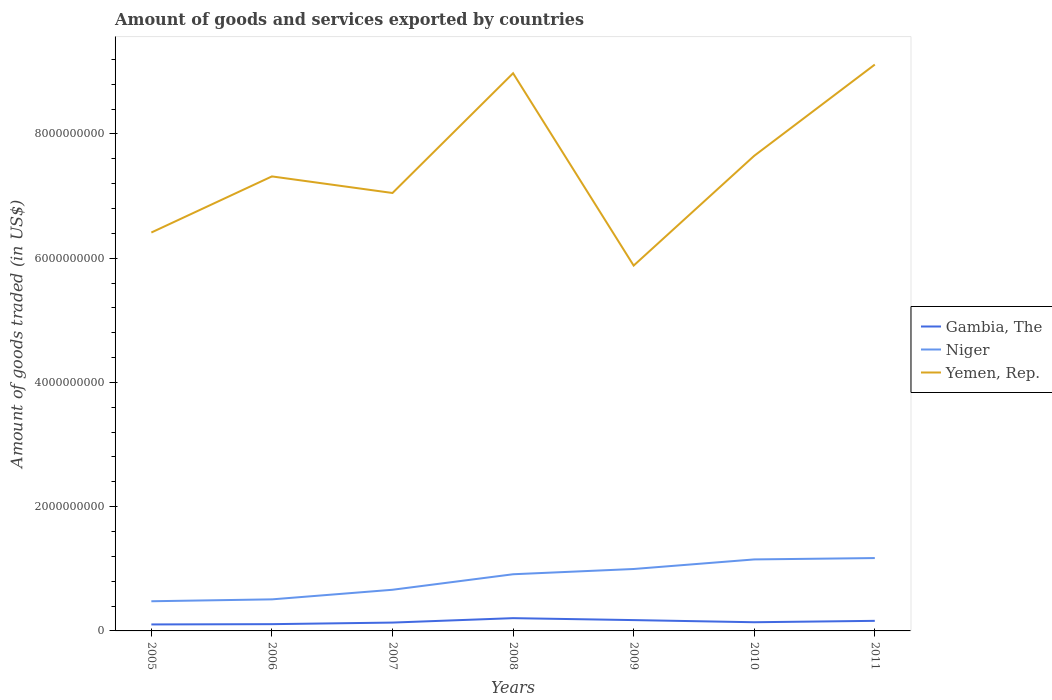Does the line corresponding to Niger intersect with the line corresponding to Gambia, The?
Offer a very short reply. No. Across all years, what is the maximum total amount of goods and services exported in Yemen, Rep.?
Offer a terse response. 5.88e+09. What is the total total amount of goods and services exported in Niger in the graph?
Your answer should be compact. -2.17e+07. What is the difference between the highest and the second highest total amount of goods and services exported in Gambia, The?
Your response must be concise. 1.01e+08. Is the total amount of goods and services exported in Niger strictly greater than the total amount of goods and services exported in Yemen, Rep. over the years?
Provide a short and direct response. Yes. How many lines are there?
Your answer should be compact. 3. How many years are there in the graph?
Provide a short and direct response. 7. What is the difference between two consecutive major ticks on the Y-axis?
Keep it short and to the point. 2.00e+09. Does the graph contain any zero values?
Ensure brevity in your answer.  No. Where does the legend appear in the graph?
Your answer should be very brief. Center right. What is the title of the graph?
Your response must be concise. Amount of goods and services exported by countries. What is the label or title of the X-axis?
Make the answer very short. Years. What is the label or title of the Y-axis?
Offer a terse response. Amount of goods traded (in US$). What is the Amount of goods traded (in US$) of Gambia, The in 2005?
Give a very brief answer. 1.04e+08. What is the Amount of goods traded (in US$) in Niger in 2005?
Provide a succinct answer. 4.78e+08. What is the Amount of goods traded (in US$) of Yemen, Rep. in 2005?
Offer a very short reply. 6.41e+09. What is the Amount of goods traded (in US$) of Gambia, The in 2006?
Your response must be concise. 1.09e+08. What is the Amount of goods traded (in US$) in Niger in 2006?
Offer a very short reply. 5.08e+08. What is the Amount of goods traded (in US$) in Yemen, Rep. in 2006?
Make the answer very short. 7.32e+09. What is the Amount of goods traded (in US$) of Gambia, The in 2007?
Your answer should be compact. 1.34e+08. What is the Amount of goods traded (in US$) of Niger in 2007?
Offer a terse response. 6.63e+08. What is the Amount of goods traded (in US$) in Yemen, Rep. in 2007?
Ensure brevity in your answer.  7.05e+09. What is the Amount of goods traded (in US$) of Gambia, The in 2008?
Offer a terse response. 2.06e+08. What is the Amount of goods traded (in US$) in Niger in 2008?
Provide a short and direct response. 9.12e+08. What is the Amount of goods traded (in US$) in Yemen, Rep. in 2008?
Give a very brief answer. 8.98e+09. What is the Amount of goods traded (in US$) in Gambia, The in 2009?
Ensure brevity in your answer.  1.74e+08. What is the Amount of goods traded (in US$) in Niger in 2009?
Your answer should be very brief. 9.97e+08. What is the Amount of goods traded (in US$) of Yemen, Rep. in 2009?
Make the answer very short. 5.88e+09. What is the Amount of goods traded (in US$) of Gambia, The in 2010?
Keep it short and to the point. 1.40e+08. What is the Amount of goods traded (in US$) of Niger in 2010?
Offer a very short reply. 1.15e+09. What is the Amount of goods traded (in US$) of Yemen, Rep. in 2010?
Provide a short and direct response. 7.65e+09. What is the Amount of goods traded (in US$) in Gambia, The in 2011?
Offer a very short reply. 1.62e+08. What is the Amount of goods traded (in US$) in Niger in 2011?
Offer a very short reply. 1.17e+09. What is the Amount of goods traded (in US$) in Yemen, Rep. in 2011?
Provide a succinct answer. 9.12e+09. Across all years, what is the maximum Amount of goods traded (in US$) in Gambia, The?
Provide a succinct answer. 2.06e+08. Across all years, what is the maximum Amount of goods traded (in US$) in Niger?
Offer a very short reply. 1.17e+09. Across all years, what is the maximum Amount of goods traded (in US$) of Yemen, Rep.?
Make the answer very short. 9.12e+09. Across all years, what is the minimum Amount of goods traded (in US$) of Gambia, The?
Your response must be concise. 1.04e+08. Across all years, what is the minimum Amount of goods traded (in US$) in Niger?
Offer a terse response. 4.78e+08. Across all years, what is the minimum Amount of goods traded (in US$) in Yemen, Rep.?
Your answer should be very brief. 5.88e+09. What is the total Amount of goods traded (in US$) of Gambia, The in the graph?
Make the answer very short. 1.03e+09. What is the total Amount of goods traded (in US$) of Niger in the graph?
Provide a short and direct response. 5.88e+09. What is the total Amount of goods traded (in US$) in Yemen, Rep. in the graph?
Provide a succinct answer. 5.24e+1. What is the difference between the Amount of goods traded (in US$) in Gambia, The in 2005 and that in 2006?
Ensure brevity in your answer.  -4.54e+06. What is the difference between the Amount of goods traded (in US$) in Niger in 2005 and that in 2006?
Make the answer very short. -3.04e+07. What is the difference between the Amount of goods traded (in US$) in Yemen, Rep. in 2005 and that in 2006?
Provide a short and direct response. -9.03e+08. What is the difference between the Amount of goods traded (in US$) of Gambia, The in 2005 and that in 2007?
Give a very brief answer. -3.00e+07. What is the difference between the Amount of goods traded (in US$) of Niger in 2005 and that in 2007?
Your answer should be compact. -1.85e+08. What is the difference between the Amount of goods traded (in US$) in Yemen, Rep. in 2005 and that in 2007?
Make the answer very short. -6.36e+08. What is the difference between the Amount of goods traded (in US$) of Gambia, The in 2005 and that in 2008?
Your answer should be very brief. -1.01e+08. What is the difference between the Amount of goods traded (in US$) in Niger in 2005 and that in 2008?
Your answer should be compact. -4.35e+08. What is the difference between the Amount of goods traded (in US$) in Yemen, Rep. in 2005 and that in 2008?
Make the answer very short. -2.56e+09. What is the difference between the Amount of goods traded (in US$) of Gambia, The in 2005 and that in 2009?
Your answer should be compact. -6.99e+07. What is the difference between the Amount of goods traded (in US$) in Niger in 2005 and that in 2009?
Ensure brevity in your answer.  -5.19e+08. What is the difference between the Amount of goods traded (in US$) of Yemen, Rep. in 2005 and that in 2009?
Provide a short and direct response. 5.32e+08. What is the difference between the Amount of goods traded (in US$) of Gambia, The in 2005 and that in 2010?
Give a very brief answer. -3.56e+07. What is the difference between the Amount of goods traded (in US$) of Niger in 2005 and that in 2010?
Offer a very short reply. -6.73e+08. What is the difference between the Amount of goods traded (in US$) in Yemen, Rep. in 2005 and that in 2010?
Keep it short and to the point. -1.24e+09. What is the difference between the Amount of goods traded (in US$) in Gambia, The in 2005 and that in 2011?
Keep it short and to the point. -5.78e+07. What is the difference between the Amount of goods traded (in US$) of Niger in 2005 and that in 2011?
Your response must be concise. -6.95e+08. What is the difference between the Amount of goods traded (in US$) in Yemen, Rep. in 2005 and that in 2011?
Offer a terse response. -2.70e+09. What is the difference between the Amount of goods traded (in US$) of Gambia, The in 2006 and that in 2007?
Your response must be concise. -2.55e+07. What is the difference between the Amount of goods traded (in US$) of Niger in 2006 and that in 2007?
Provide a succinct answer. -1.55e+08. What is the difference between the Amount of goods traded (in US$) in Yemen, Rep. in 2006 and that in 2007?
Provide a short and direct response. 2.67e+08. What is the difference between the Amount of goods traded (in US$) in Gambia, The in 2006 and that in 2008?
Make the answer very short. -9.66e+07. What is the difference between the Amount of goods traded (in US$) of Niger in 2006 and that in 2008?
Your response must be concise. -4.04e+08. What is the difference between the Amount of goods traded (in US$) of Yemen, Rep. in 2006 and that in 2008?
Keep it short and to the point. -1.66e+09. What is the difference between the Amount of goods traded (in US$) of Gambia, The in 2006 and that in 2009?
Your response must be concise. -6.53e+07. What is the difference between the Amount of goods traded (in US$) of Niger in 2006 and that in 2009?
Provide a short and direct response. -4.89e+08. What is the difference between the Amount of goods traded (in US$) in Yemen, Rep. in 2006 and that in 2009?
Offer a terse response. 1.44e+09. What is the difference between the Amount of goods traded (in US$) of Gambia, The in 2006 and that in 2010?
Your response must be concise. -3.11e+07. What is the difference between the Amount of goods traded (in US$) in Niger in 2006 and that in 2010?
Your answer should be compact. -6.43e+08. What is the difference between the Amount of goods traded (in US$) in Yemen, Rep. in 2006 and that in 2010?
Keep it short and to the point. -3.32e+08. What is the difference between the Amount of goods traded (in US$) in Gambia, The in 2006 and that in 2011?
Your response must be concise. -5.33e+07. What is the difference between the Amount of goods traded (in US$) in Niger in 2006 and that in 2011?
Provide a short and direct response. -6.65e+08. What is the difference between the Amount of goods traded (in US$) in Yemen, Rep. in 2006 and that in 2011?
Ensure brevity in your answer.  -1.80e+09. What is the difference between the Amount of goods traded (in US$) in Gambia, The in 2007 and that in 2008?
Make the answer very short. -7.12e+07. What is the difference between the Amount of goods traded (in US$) in Niger in 2007 and that in 2008?
Make the answer very short. -2.50e+08. What is the difference between the Amount of goods traded (in US$) in Yemen, Rep. in 2007 and that in 2008?
Your answer should be very brief. -1.93e+09. What is the difference between the Amount of goods traded (in US$) in Gambia, The in 2007 and that in 2009?
Your answer should be compact. -3.99e+07. What is the difference between the Amount of goods traded (in US$) in Niger in 2007 and that in 2009?
Your answer should be compact. -3.34e+08. What is the difference between the Amount of goods traded (in US$) in Yemen, Rep. in 2007 and that in 2009?
Provide a short and direct response. 1.17e+09. What is the difference between the Amount of goods traded (in US$) of Gambia, The in 2007 and that in 2010?
Make the answer very short. -5.60e+06. What is the difference between the Amount of goods traded (in US$) of Niger in 2007 and that in 2010?
Your answer should be compact. -4.88e+08. What is the difference between the Amount of goods traded (in US$) of Yemen, Rep. in 2007 and that in 2010?
Offer a very short reply. -5.99e+08. What is the difference between the Amount of goods traded (in US$) in Gambia, The in 2007 and that in 2011?
Give a very brief answer. -2.78e+07. What is the difference between the Amount of goods traded (in US$) of Niger in 2007 and that in 2011?
Make the answer very short. -5.10e+08. What is the difference between the Amount of goods traded (in US$) of Yemen, Rep. in 2007 and that in 2011?
Your response must be concise. -2.07e+09. What is the difference between the Amount of goods traded (in US$) of Gambia, The in 2008 and that in 2009?
Ensure brevity in your answer.  3.13e+07. What is the difference between the Amount of goods traded (in US$) in Niger in 2008 and that in 2009?
Keep it short and to the point. -8.47e+07. What is the difference between the Amount of goods traded (in US$) in Yemen, Rep. in 2008 and that in 2009?
Your answer should be very brief. 3.10e+09. What is the difference between the Amount of goods traded (in US$) in Gambia, The in 2008 and that in 2010?
Provide a short and direct response. 6.56e+07. What is the difference between the Amount of goods traded (in US$) of Niger in 2008 and that in 2010?
Make the answer very short. -2.39e+08. What is the difference between the Amount of goods traded (in US$) in Yemen, Rep. in 2008 and that in 2010?
Provide a short and direct response. 1.33e+09. What is the difference between the Amount of goods traded (in US$) in Gambia, The in 2008 and that in 2011?
Your answer should be compact. 4.34e+07. What is the difference between the Amount of goods traded (in US$) of Niger in 2008 and that in 2011?
Provide a succinct answer. -2.61e+08. What is the difference between the Amount of goods traded (in US$) of Yemen, Rep. in 2008 and that in 2011?
Provide a short and direct response. -1.40e+08. What is the difference between the Amount of goods traded (in US$) in Gambia, The in 2009 and that in 2010?
Give a very brief answer. 3.43e+07. What is the difference between the Amount of goods traded (in US$) of Niger in 2009 and that in 2010?
Your answer should be compact. -1.54e+08. What is the difference between the Amount of goods traded (in US$) in Yemen, Rep. in 2009 and that in 2010?
Provide a succinct answer. -1.77e+09. What is the difference between the Amount of goods traded (in US$) in Gambia, The in 2009 and that in 2011?
Offer a very short reply. 1.21e+07. What is the difference between the Amount of goods traded (in US$) of Niger in 2009 and that in 2011?
Your answer should be very brief. -1.76e+08. What is the difference between the Amount of goods traded (in US$) in Yemen, Rep. in 2009 and that in 2011?
Your answer should be very brief. -3.24e+09. What is the difference between the Amount of goods traded (in US$) of Gambia, The in 2010 and that in 2011?
Keep it short and to the point. -2.22e+07. What is the difference between the Amount of goods traded (in US$) of Niger in 2010 and that in 2011?
Your answer should be very brief. -2.17e+07. What is the difference between the Amount of goods traded (in US$) in Yemen, Rep. in 2010 and that in 2011?
Offer a terse response. -1.47e+09. What is the difference between the Amount of goods traded (in US$) in Gambia, The in 2005 and the Amount of goods traded (in US$) in Niger in 2006?
Your answer should be compact. -4.04e+08. What is the difference between the Amount of goods traded (in US$) in Gambia, The in 2005 and the Amount of goods traded (in US$) in Yemen, Rep. in 2006?
Provide a short and direct response. -7.21e+09. What is the difference between the Amount of goods traded (in US$) in Niger in 2005 and the Amount of goods traded (in US$) in Yemen, Rep. in 2006?
Keep it short and to the point. -6.84e+09. What is the difference between the Amount of goods traded (in US$) of Gambia, The in 2005 and the Amount of goods traded (in US$) of Niger in 2007?
Ensure brevity in your answer.  -5.58e+08. What is the difference between the Amount of goods traded (in US$) of Gambia, The in 2005 and the Amount of goods traded (in US$) of Yemen, Rep. in 2007?
Offer a very short reply. -6.95e+09. What is the difference between the Amount of goods traded (in US$) of Niger in 2005 and the Amount of goods traded (in US$) of Yemen, Rep. in 2007?
Offer a very short reply. -6.57e+09. What is the difference between the Amount of goods traded (in US$) in Gambia, The in 2005 and the Amount of goods traded (in US$) in Niger in 2008?
Offer a terse response. -8.08e+08. What is the difference between the Amount of goods traded (in US$) in Gambia, The in 2005 and the Amount of goods traded (in US$) in Yemen, Rep. in 2008?
Provide a short and direct response. -8.87e+09. What is the difference between the Amount of goods traded (in US$) in Niger in 2005 and the Amount of goods traded (in US$) in Yemen, Rep. in 2008?
Offer a terse response. -8.50e+09. What is the difference between the Amount of goods traded (in US$) of Gambia, The in 2005 and the Amount of goods traded (in US$) of Niger in 2009?
Your answer should be compact. -8.93e+08. What is the difference between the Amount of goods traded (in US$) of Gambia, The in 2005 and the Amount of goods traded (in US$) of Yemen, Rep. in 2009?
Your answer should be compact. -5.78e+09. What is the difference between the Amount of goods traded (in US$) in Niger in 2005 and the Amount of goods traded (in US$) in Yemen, Rep. in 2009?
Your answer should be very brief. -5.40e+09. What is the difference between the Amount of goods traded (in US$) of Gambia, The in 2005 and the Amount of goods traded (in US$) of Niger in 2010?
Keep it short and to the point. -1.05e+09. What is the difference between the Amount of goods traded (in US$) of Gambia, The in 2005 and the Amount of goods traded (in US$) of Yemen, Rep. in 2010?
Offer a very short reply. -7.54e+09. What is the difference between the Amount of goods traded (in US$) in Niger in 2005 and the Amount of goods traded (in US$) in Yemen, Rep. in 2010?
Make the answer very short. -7.17e+09. What is the difference between the Amount of goods traded (in US$) in Gambia, The in 2005 and the Amount of goods traded (in US$) in Niger in 2011?
Make the answer very short. -1.07e+09. What is the difference between the Amount of goods traded (in US$) in Gambia, The in 2005 and the Amount of goods traded (in US$) in Yemen, Rep. in 2011?
Provide a succinct answer. -9.01e+09. What is the difference between the Amount of goods traded (in US$) of Niger in 2005 and the Amount of goods traded (in US$) of Yemen, Rep. in 2011?
Your answer should be very brief. -8.64e+09. What is the difference between the Amount of goods traded (in US$) in Gambia, The in 2006 and the Amount of goods traded (in US$) in Niger in 2007?
Keep it short and to the point. -5.54e+08. What is the difference between the Amount of goods traded (in US$) of Gambia, The in 2006 and the Amount of goods traded (in US$) of Yemen, Rep. in 2007?
Provide a short and direct response. -6.94e+09. What is the difference between the Amount of goods traded (in US$) of Niger in 2006 and the Amount of goods traded (in US$) of Yemen, Rep. in 2007?
Your response must be concise. -6.54e+09. What is the difference between the Amount of goods traded (in US$) of Gambia, The in 2006 and the Amount of goods traded (in US$) of Niger in 2008?
Offer a terse response. -8.03e+08. What is the difference between the Amount of goods traded (in US$) in Gambia, The in 2006 and the Amount of goods traded (in US$) in Yemen, Rep. in 2008?
Your answer should be compact. -8.87e+09. What is the difference between the Amount of goods traded (in US$) of Niger in 2006 and the Amount of goods traded (in US$) of Yemen, Rep. in 2008?
Provide a succinct answer. -8.47e+09. What is the difference between the Amount of goods traded (in US$) of Gambia, The in 2006 and the Amount of goods traded (in US$) of Niger in 2009?
Give a very brief answer. -8.88e+08. What is the difference between the Amount of goods traded (in US$) of Gambia, The in 2006 and the Amount of goods traded (in US$) of Yemen, Rep. in 2009?
Keep it short and to the point. -5.77e+09. What is the difference between the Amount of goods traded (in US$) of Niger in 2006 and the Amount of goods traded (in US$) of Yemen, Rep. in 2009?
Your answer should be compact. -5.37e+09. What is the difference between the Amount of goods traded (in US$) in Gambia, The in 2006 and the Amount of goods traded (in US$) in Niger in 2010?
Give a very brief answer. -1.04e+09. What is the difference between the Amount of goods traded (in US$) of Gambia, The in 2006 and the Amount of goods traded (in US$) of Yemen, Rep. in 2010?
Provide a short and direct response. -7.54e+09. What is the difference between the Amount of goods traded (in US$) in Niger in 2006 and the Amount of goods traded (in US$) in Yemen, Rep. in 2010?
Provide a short and direct response. -7.14e+09. What is the difference between the Amount of goods traded (in US$) of Gambia, The in 2006 and the Amount of goods traded (in US$) of Niger in 2011?
Provide a short and direct response. -1.06e+09. What is the difference between the Amount of goods traded (in US$) of Gambia, The in 2006 and the Amount of goods traded (in US$) of Yemen, Rep. in 2011?
Your response must be concise. -9.01e+09. What is the difference between the Amount of goods traded (in US$) in Niger in 2006 and the Amount of goods traded (in US$) in Yemen, Rep. in 2011?
Make the answer very short. -8.61e+09. What is the difference between the Amount of goods traded (in US$) of Gambia, The in 2007 and the Amount of goods traded (in US$) of Niger in 2008?
Your answer should be compact. -7.78e+08. What is the difference between the Amount of goods traded (in US$) of Gambia, The in 2007 and the Amount of goods traded (in US$) of Yemen, Rep. in 2008?
Provide a short and direct response. -8.84e+09. What is the difference between the Amount of goods traded (in US$) in Niger in 2007 and the Amount of goods traded (in US$) in Yemen, Rep. in 2008?
Offer a terse response. -8.31e+09. What is the difference between the Amount of goods traded (in US$) of Gambia, The in 2007 and the Amount of goods traded (in US$) of Niger in 2009?
Provide a short and direct response. -8.63e+08. What is the difference between the Amount of goods traded (in US$) in Gambia, The in 2007 and the Amount of goods traded (in US$) in Yemen, Rep. in 2009?
Offer a terse response. -5.75e+09. What is the difference between the Amount of goods traded (in US$) in Niger in 2007 and the Amount of goods traded (in US$) in Yemen, Rep. in 2009?
Ensure brevity in your answer.  -5.22e+09. What is the difference between the Amount of goods traded (in US$) of Gambia, The in 2007 and the Amount of goods traded (in US$) of Niger in 2010?
Provide a succinct answer. -1.02e+09. What is the difference between the Amount of goods traded (in US$) in Gambia, The in 2007 and the Amount of goods traded (in US$) in Yemen, Rep. in 2010?
Offer a very short reply. -7.51e+09. What is the difference between the Amount of goods traded (in US$) in Niger in 2007 and the Amount of goods traded (in US$) in Yemen, Rep. in 2010?
Your response must be concise. -6.99e+09. What is the difference between the Amount of goods traded (in US$) in Gambia, The in 2007 and the Amount of goods traded (in US$) in Niger in 2011?
Your answer should be compact. -1.04e+09. What is the difference between the Amount of goods traded (in US$) in Gambia, The in 2007 and the Amount of goods traded (in US$) in Yemen, Rep. in 2011?
Your answer should be very brief. -8.98e+09. What is the difference between the Amount of goods traded (in US$) in Niger in 2007 and the Amount of goods traded (in US$) in Yemen, Rep. in 2011?
Offer a terse response. -8.45e+09. What is the difference between the Amount of goods traded (in US$) in Gambia, The in 2008 and the Amount of goods traded (in US$) in Niger in 2009?
Provide a short and direct response. -7.91e+08. What is the difference between the Amount of goods traded (in US$) in Gambia, The in 2008 and the Amount of goods traded (in US$) in Yemen, Rep. in 2009?
Keep it short and to the point. -5.68e+09. What is the difference between the Amount of goods traded (in US$) in Niger in 2008 and the Amount of goods traded (in US$) in Yemen, Rep. in 2009?
Provide a short and direct response. -4.97e+09. What is the difference between the Amount of goods traded (in US$) of Gambia, The in 2008 and the Amount of goods traded (in US$) of Niger in 2010?
Provide a succinct answer. -9.46e+08. What is the difference between the Amount of goods traded (in US$) of Gambia, The in 2008 and the Amount of goods traded (in US$) of Yemen, Rep. in 2010?
Keep it short and to the point. -7.44e+09. What is the difference between the Amount of goods traded (in US$) in Niger in 2008 and the Amount of goods traded (in US$) in Yemen, Rep. in 2010?
Provide a short and direct response. -6.74e+09. What is the difference between the Amount of goods traded (in US$) in Gambia, The in 2008 and the Amount of goods traded (in US$) in Niger in 2011?
Your answer should be compact. -9.67e+08. What is the difference between the Amount of goods traded (in US$) in Gambia, The in 2008 and the Amount of goods traded (in US$) in Yemen, Rep. in 2011?
Make the answer very short. -8.91e+09. What is the difference between the Amount of goods traded (in US$) in Niger in 2008 and the Amount of goods traded (in US$) in Yemen, Rep. in 2011?
Your response must be concise. -8.20e+09. What is the difference between the Amount of goods traded (in US$) of Gambia, The in 2009 and the Amount of goods traded (in US$) of Niger in 2010?
Provide a succinct answer. -9.77e+08. What is the difference between the Amount of goods traded (in US$) in Gambia, The in 2009 and the Amount of goods traded (in US$) in Yemen, Rep. in 2010?
Your response must be concise. -7.47e+09. What is the difference between the Amount of goods traded (in US$) of Niger in 2009 and the Amount of goods traded (in US$) of Yemen, Rep. in 2010?
Ensure brevity in your answer.  -6.65e+09. What is the difference between the Amount of goods traded (in US$) of Gambia, The in 2009 and the Amount of goods traded (in US$) of Niger in 2011?
Your answer should be compact. -9.99e+08. What is the difference between the Amount of goods traded (in US$) in Gambia, The in 2009 and the Amount of goods traded (in US$) in Yemen, Rep. in 2011?
Give a very brief answer. -8.94e+09. What is the difference between the Amount of goods traded (in US$) of Niger in 2009 and the Amount of goods traded (in US$) of Yemen, Rep. in 2011?
Provide a succinct answer. -8.12e+09. What is the difference between the Amount of goods traded (in US$) in Gambia, The in 2010 and the Amount of goods traded (in US$) in Niger in 2011?
Keep it short and to the point. -1.03e+09. What is the difference between the Amount of goods traded (in US$) of Gambia, The in 2010 and the Amount of goods traded (in US$) of Yemen, Rep. in 2011?
Your answer should be very brief. -8.98e+09. What is the difference between the Amount of goods traded (in US$) of Niger in 2010 and the Amount of goods traded (in US$) of Yemen, Rep. in 2011?
Give a very brief answer. -7.97e+09. What is the average Amount of goods traded (in US$) in Gambia, The per year?
Offer a terse response. 1.47e+08. What is the average Amount of goods traded (in US$) of Niger per year?
Your answer should be very brief. 8.40e+08. What is the average Amount of goods traded (in US$) in Yemen, Rep. per year?
Keep it short and to the point. 7.49e+09. In the year 2005, what is the difference between the Amount of goods traded (in US$) in Gambia, The and Amount of goods traded (in US$) in Niger?
Provide a succinct answer. -3.73e+08. In the year 2005, what is the difference between the Amount of goods traded (in US$) in Gambia, The and Amount of goods traded (in US$) in Yemen, Rep.?
Offer a very short reply. -6.31e+09. In the year 2005, what is the difference between the Amount of goods traded (in US$) of Niger and Amount of goods traded (in US$) of Yemen, Rep.?
Your response must be concise. -5.94e+09. In the year 2006, what is the difference between the Amount of goods traded (in US$) in Gambia, The and Amount of goods traded (in US$) in Niger?
Your answer should be very brief. -3.99e+08. In the year 2006, what is the difference between the Amount of goods traded (in US$) in Gambia, The and Amount of goods traded (in US$) in Yemen, Rep.?
Give a very brief answer. -7.21e+09. In the year 2006, what is the difference between the Amount of goods traded (in US$) in Niger and Amount of goods traded (in US$) in Yemen, Rep.?
Make the answer very short. -6.81e+09. In the year 2007, what is the difference between the Amount of goods traded (in US$) of Gambia, The and Amount of goods traded (in US$) of Niger?
Make the answer very short. -5.28e+08. In the year 2007, what is the difference between the Amount of goods traded (in US$) of Gambia, The and Amount of goods traded (in US$) of Yemen, Rep.?
Provide a succinct answer. -6.92e+09. In the year 2007, what is the difference between the Amount of goods traded (in US$) in Niger and Amount of goods traded (in US$) in Yemen, Rep.?
Provide a succinct answer. -6.39e+09. In the year 2008, what is the difference between the Amount of goods traded (in US$) in Gambia, The and Amount of goods traded (in US$) in Niger?
Your answer should be compact. -7.07e+08. In the year 2008, what is the difference between the Amount of goods traded (in US$) in Gambia, The and Amount of goods traded (in US$) in Yemen, Rep.?
Provide a short and direct response. -8.77e+09. In the year 2008, what is the difference between the Amount of goods traded (in US$) in Niger and Amount of goods traded (in US$) in Yemen, Rep.?
Ensure brevity in your answer.  -8.06e+09. In the year 2009, what is the difference between the Amount of goods traded (in US$) in Gambia, The and Amount of goods traded (in US$) in Niger?
Offer a terse response. -8.23e+08. In the year 2009, what is the difference between the Amount of goods traded (in US$) of Gambia, The and Amount of goods traded (in US$) of Yemen, Rep.?
Ensure brevity in your answer.  -5.71e+09. In the year 2009, what is the difference between the Amount of goods traded (in US$) of Niger and Amount of goods traded (in US$) of Yemen, Rep.?
Ensure brevity in your answer.  -4.88e+09. In the year 2010, what is the difference between the Amount of goods traded (in US$) in Gambia, The and Amount of goods traded (in US$) in Niger?
Your answer should be compact. -1.01e+09. In the year 2010, what is the difference between the Amount of goods traded (in US$) of Gambia, The and Amount of goods traded (in US$) of Yemen, Rep.?
Your response must be concise. -7.51e+09. In the year 2010, what is the difference between the Amount of goods traded (in US$) in Niger and Amount of goods traded (in US$) in Yemen, Rep.?
Provide a short and direct response. -6.50e+09. In the year 2011, what is the difference between the Amount of goods traded (in US$) of Gambia, The and Amount of goods traded (in US$) of Niger?
Offer a very short reply. -1.01e+09. In the year 2011, what is the difference between the Amount of goods traded (in US$) of Gambia, The and Amount of goods traded (in US$) of Yemen, Rep.?
Offer a terse response. -8.95e+09. In the year 2011, what is the difference between the Amount of goods traded (in US$) of Niger and Amount of goods traded (in US$) of Yemen, Rep.?
Your response must be concise. -7.94e+09. What is the ratio of the Amount of goods traded (in US$) of Gambia, The in 2005 to that in 2006?
Ensure brevity in your answer.  0.96. What is the ratio of the Amount of goods traded (in US$) of Niger in 2005 to that in 2006?
Provide a succinct answer. 0.94. What is the ratio of the Amount of goods traded (in US$) of Yemen, Rep. in 2005 to that in 2006?
Your answer should be compact. 0.88. What is the ratio of the Amount of goods traded (in US$) in Gambia, The in 2005 to that in 2007?
Your answer should be very brief. 0.78. What is the ratio of the Amount of goods traded (in US$) of Niger in 2005 to that in 2007?
Your answer should be very brief. 0.72. What is the ratio of the Amount of goods traded (in US$) in Yemen, Rep. in 2005 to that in 2007?
Offer a terse response. 0.91. What is the ratio of the Amount of goods traded (in US$) in Gambia, The in 2005 to that in 2008?
Your answer should be compact. 0.51. What is the ratio of the Amount of goods traded (in US$) of Niger in 2005 to that in 2008?
Your answer should be very brief. 0.52. What is the ratio of the Amount of goods traded (in US$) in Yemen, Rep. in 2005 to that in 2008?
Offer a terse response. 0.71. What is the ratio of the Amount of goods traded (in US$) in Gambia, The in 2005 to that in 2009?
Your response must be concise. 0.6. What is the ratio of the Amount of goods traded (in US$) in Niger in 2005 to that in 2009?
Make the answer very short. 0.48. What is the ratio of the Amount of goods traded (in US$) in Yemen, Rep. in 2005 to that in 2009?
Provide a short and direct response. 1.09. What is the ratio of the Amount of goods traded (in US$) in Gambia, The in 2005 to that in 2010?
Offer a very short reply. 0.75. What is the ratio of the Amount of goods traded (in US$) of Niger in 2005 to that in 2010?
Provide a succinct answer. 0.41. What is the ratio of the Amount of goods traded (in US$) of Yemen, Rep. in 2005 to that in 2010?
Offer a terse response. 0.84. What is the ratio of the Amount of goods traded (in US$) of Gambia, The in 2005 to that in 2011?
Offer a very short reply. 0.64. What is the ratio of the Amount of goods traded (in US$) in Niger in 2005 to that in 2011?
Provide a short and direct response. 0.41. What is the ratio of the Amount of goods traded (in US$) in Yemen, Rep. in 2005 to that in 2011?
Your answer should be compact. 0.7. What is the ratio of the Amount of goods traded (in US$) in Gambia, The in 2006 to that in 2007?
Your answer should be compact. 0.81. What is the ratio of the Amount of goods traded (in US$) in Niger in 2006 to that in 2007?
Your answer should be very brief. 0.77. What is the ratio of the Amount of goods traded (in US$) in Yemen, Rep. in 2006 to that in 2007?
Ensure brevity in your answer.  1.04. What is the ratio of the Amount of goods traded (in US$) of Gambia, The in 2006 to that in 2008?
Ensure brevity in your answer.  0.53. What is the ratio of the Amount of goods traded (in US$) in Niger in 2006 to that in 2008?
Keep it short and to the point. 0.56. What is the ratio of the Amount of goods traded (in US$) in Yemen, Rep. in 2006 to that in 2008?
Provide a short and direct response. 0.81. What is the ratio of the Amount of goods traded (in US$) in Gambia, The in 2006 to that in 2009?
Offer a very short reply. 0.62. What is the ratio of the Amount of goods traded (in US$) of Niger in 2006 to that in 2009?
Your response must be concise. 0.51. What is the ratio of the Amount of goods traded (in US$) of Yemen, Rep. in 2006 to that in 2009?
Provide a succinct answer. 1.24. What is the ratio of the Amount of goods traded (in US$) in Gambia, The in 2006 to that in 2010?
Your answer should be compact. 0.78. What is the ratio of the Amount of goods traded (in US$) of Niger in 2006 to that in 2010?
Your answer should be compact. 0.44. What is the ratio of the Amount of goods traded (in US$) of Yemen, Rep. in 2006 to that in 2010?
Ensure brevity in your answer.  0.96. What is the ratio of the Amount of goods traded (in US$) of Gambia, The in 2006 to that in 2011?
Ensure brevity in your answer.  0.67. What is the ratio of the Amount of goods traded (in US$) in Niger in 2006 to that in 2011?
Ensure brevity in your answer.  0.43. What is the ratio of the Amount of goods traded (in US$) in Yemen, Rep. in 2006 to that in 2011?
Your answer should be compact. 0.8. What is the ratio of the Amount of goods traded (in US$) of Gambia, The in 2007 to that in 2008?
Provide a short and direct response. 0.65. What is the ratio of the Amount of goods traded (in US$) in Niger in 2007 to that in 2008?
Give a very brief answer. 0.73. What is the ratio of the Amount of goods traded (in US$) of Yemen, Rep. in 2007 to that in 2008?
Offer a terse response. 0.79. What is the ratio of the Amount of goods traded (in US$) of Gambia, The in 2007 to that in 2009?
Provide a succinct answer. 0.77. What is the ratio of the Amount of goods traded (in US$) of Niger in 2007 to that in 2009?
Offer a terse response. 0.66. What is the ratio of the Amount of goods traded (in US$) in Yemen, Rep. in 2007 to that in 2009?
Provide a succinct answer. 1.2. What is the ratio of the Amount of goods traded (in US$) in Gambia, The in 2007 to that in 2010?
Your answer should be very brief. 0.96. What is the ratio of the Amount of goods traded (in US$) in Niger in 2007 to that in 2010?
Provide a short and direct response. 0.58. What is the ratio of the Amount of goods traded (in US$) in Yemen, Rep. in 2007 to that in 2010?
Your answer should be very brief. 0.92. What is the ratio of the Amount of goods traded (in US$) in Gambia, The in 2007 to that in 2011?
Offer a very short reply. 0.83. What is the ratio of the Amount of goods traded (in US$) in Niger in 2007 to that in 2011?
Provide a short and direct response. 0.56. What is the ratio of the Amount of goods traded (in US$) of Yemen, Rep. in 2007 to that in 2011?
Ensure brevity in your answer.  0.77. What is the ratio of the Amount of goods traded (in US$) in Gambia, The in 2008 to that in 2009?
Offer a very short reply. 1.18. What is the ratio of the Amount of goods traded (in US$) in Niger in 2008 to that in 2009?
Provide a short and direct response. 0.92. What is the ratio of the Amount of goods traded (in US$) in Yemen, Rep. in 2008 to that in 2009?
Offer a terse response. 1.53. What is the ratio of the Amount of goods traded (in US$) of Gambia, The in 2008 to that in 2010?
Provide a succinct answer. 1.47. What is the ratio of the Amount of goods traded (in US$) in Niger in 2008 to that in 2010?
Provide a succinct answer. 0.79. What is the ratio of the Amount of goods traded (in US$) of Yemen, Rep. in 2008 to that in 2010?
Your answer should be compact. 1.17. What is the ratio of the Amount of goods traded (in US$) of Gambia, The in 2008 to that in 2011?
Offer a terse response. 1.27. What is the ratio of the Amount of goods traded (in US$) in Yemen, Rep. in 2008 to that in 2011?
Your response must be concise. 0.98. What is the ratio of the Amount of goods traded (in US$) in Gambia, The in 2009 to that in 2010?
Offer a terse response. 1.25. What is the ratio of the Amount of goods traded (in US$) in Niger in 2009 to that in 2010?
Keep it short and to the point. 0.87. What is the ratio of the Amount of goods traded (in US$) of Yemen, Rep. in 2009 to that in 2010?
Offer a very short reply. 0.77. What is the ratio of the Amount of goods traded (in US$) in Gambia, The in 2009 to that in 2011?
Your answer should be compact. 1.07. What is the ratio of the Amount of goods traded (in US$) of Niger in 2009 to that in 2011?
Keep it short and to the point. 0.85. What is the ratio of the Amount of goods traded (in US$) in Yemen, Rep. in 2009 to that in 2011?
Your answer should be very brief. 0.65. What is the ratio of the Amount of goods traded (in US$) of Gambia, The in 2010 to that in 2011?
Your answer should be compact. 0.86. What is the ratio of the Amount of goods traded (in US$) of Niger in 2010 to that in 2011?
Offer a terse response. 0.98. What is the ratio of the Amount of goods traded (in US$) in Yemen, Rep. in 2010 to that in 2011?
Offer a very short reply. 0.84. What is the difference between the highest and the second highest Amount of goods traded (in US$) in Gambia, The?
Provide a succinct answer. 3.13e+07. What is the difference between the highest and the second highest Amount of goods traded (in US$) of Niger?
Offer a terse response. 2.17e+07. What is the difference between the highest and the second highest Amount of goods traded (in US$) in Yemen, Rep.?
Provide a short and direct response. 1.40e+08. What is the difference between the highest and the lowest Amount of goods traded (in US$) in Gambia, The?
Provide a succinct answer. 1.01e+08. What is the difference between the highest and the lowest Amount of goods traded (in US$) of Niger?
Keep it short and to the point. 6.95e+08. What is the difference between the highest and the lowest Amount of goods traded (in US$) in Yemen, Rep.?
Offer a terse response. 3.24e+09. 